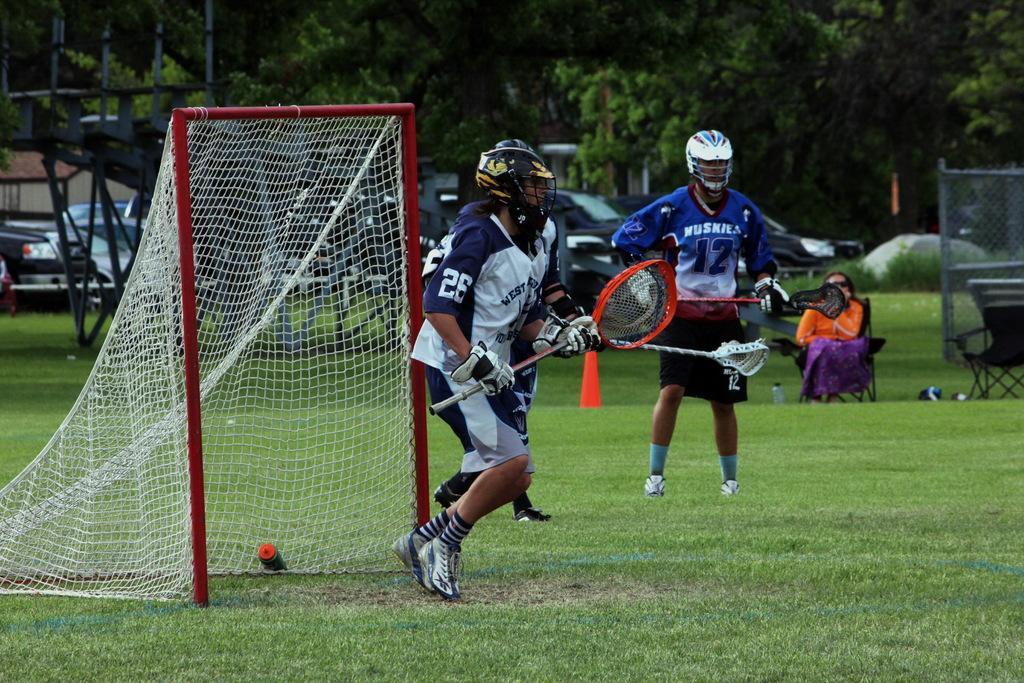Can you describe this image briefly? In this picture I can see there are few persons standing and they are wearing jersey´s and they are wearing helmets and holding few objects in the hand and there is a net at left and there is grass on the floor and there are few cars parked in the backdrop and there are trees. There is a woman sitting on the chair in the backdrop. 